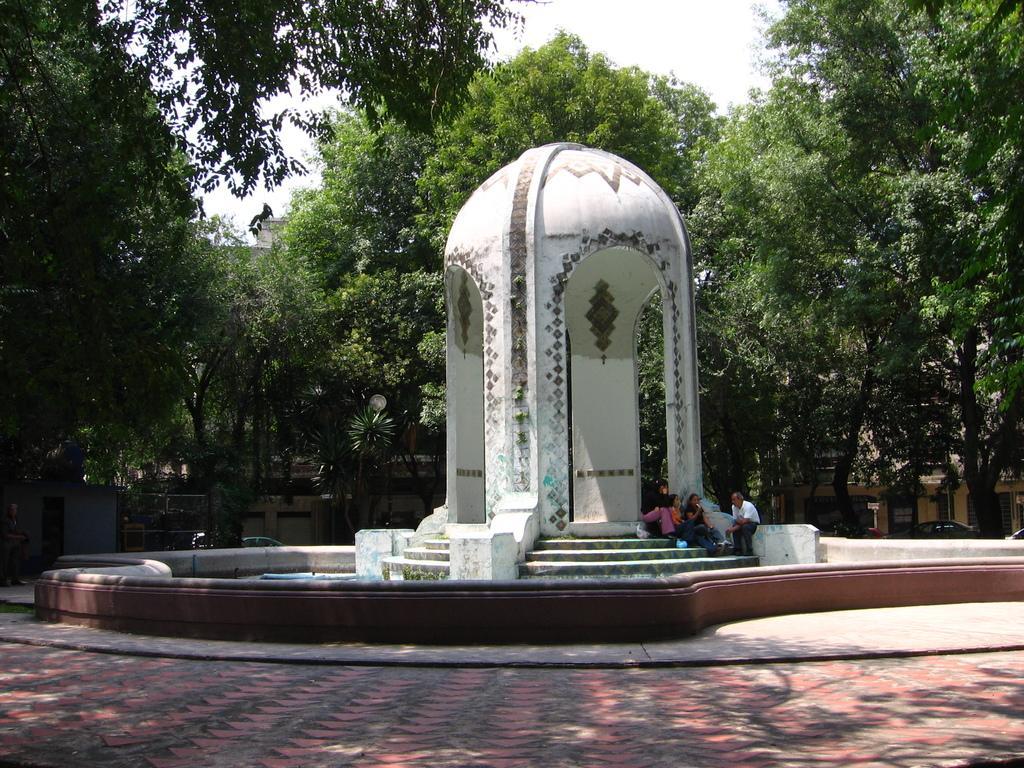Could you give a brief overview of what you see in this image? In the image we can see the arch design construction and there are people sitting, wearing clothes. Here we can see stairs, footpath, trees and the sky. 